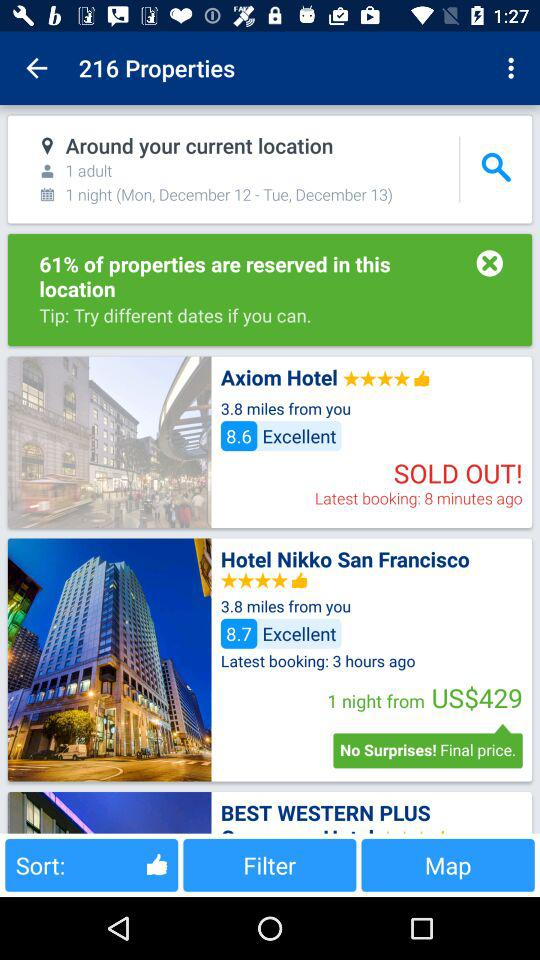How many adults are there? There is 1 adult. 